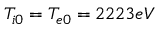<formula> <loc_0><loc_0><loc_500><loc_500>T _ { i 0 } = T _ { e 0 } = 2 2 2 3 e V</formula> 